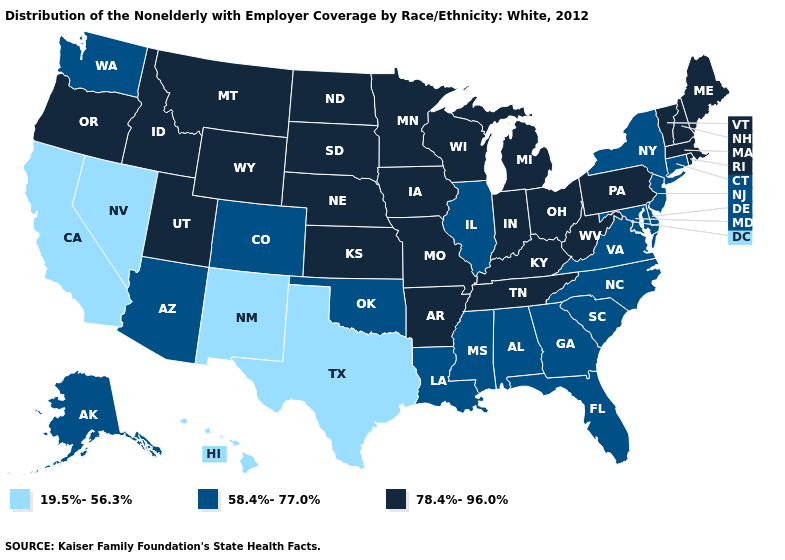Name the states that have a value in the range 78.4%-96.0%?
Give a very brief answer. Arkansas, Idaho, Indiana, Iowa, Kansas, Kentucky, Maine, Massachusetts, Michigan, Minnesota, Missouri, Montana, Nebraska, New Hampshire, North Dakota, Ohio, Oregon, Pennsylvania, Rhode Island, South Dakota, Tennessee, Utah, Vermont, West Virginia, Wisconsin, Wyoming. What is the value of Nebraska?
Short answer required. 78.4%-96.0%. Name the states that have a value in the range 78.4%-96.0%?
Answer briefly. Arkansas, Idaho, Indiana, Iowa, Kansas, Kentucky, Maine, Massachusetts, Michigan, Minnesota, Missouri, Montana, Nebraska, New Hampshire, North Dakota, Ohio, Oregon, Pennsylvania, Rhode Island, South Dakota, Tennessee, Utah, Vermont, West Virginia, Wisconsin, Wyoming. Does the map have missing data?
Write a very short answer. No. Name the states that have a value in the range 19.5%-56.3%?
Quick response, please. California, Hawaii, Nevada, New Mexico, Texas. Does Washington have the highest value in the USA?
Give a very brief answer. No. How many symbols are there in the legend?
Quick response, please. 3. Which states hav the highest value in the South?
Short answer required. Arkansas, Kentucky, Tennessee, West Virginia. Among the states that border Washington , which have the highest value?
Quick response, please. Idaho, Oregon. Does California have the lowest value in the USA?
Short answer required. Yes. Does Kentucky have a higher value than Illinois?
Short answer required. Yes. Does Massachusetts have the highest value in the USA?
Concise answer only. Yes. What is the value of Wyoming?
Give a very brief answer. 78.4%-96.0%. Which states have the lowest value in the USA?
Give a very brief answer. California, Hawaii, Nevada, New Mexico, Texas. 